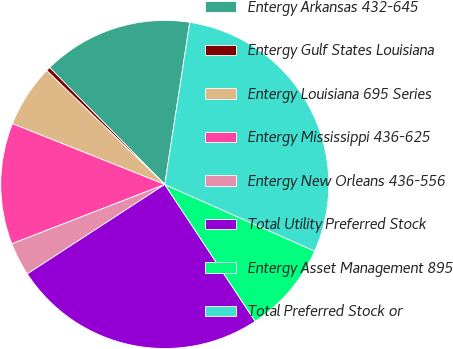Convert chart. <chart><loc_0><loc_0><loc_500><loc_500><pie_chart><fcel>Entergy Arkansas 432-645<fcel>Entergy Gulf States Louisiana<fcel>Entergy Louisiana 695 Series<fcel>Entergy Mississippi 436-625<fcel>Entergy New Orleans 436-556<fcel>Total Utility Preferred Stock<fcel>Entergy Asset Management 895<fcel>Total Preferred Stock or<nl><fcel>14.81%<fcel>0.41%<fcel>6.17%<fcel>11.93%<fcel>3.29%<fcel>25.11%<fcel>9.05%<fcel>29.22%<nl></chart> 